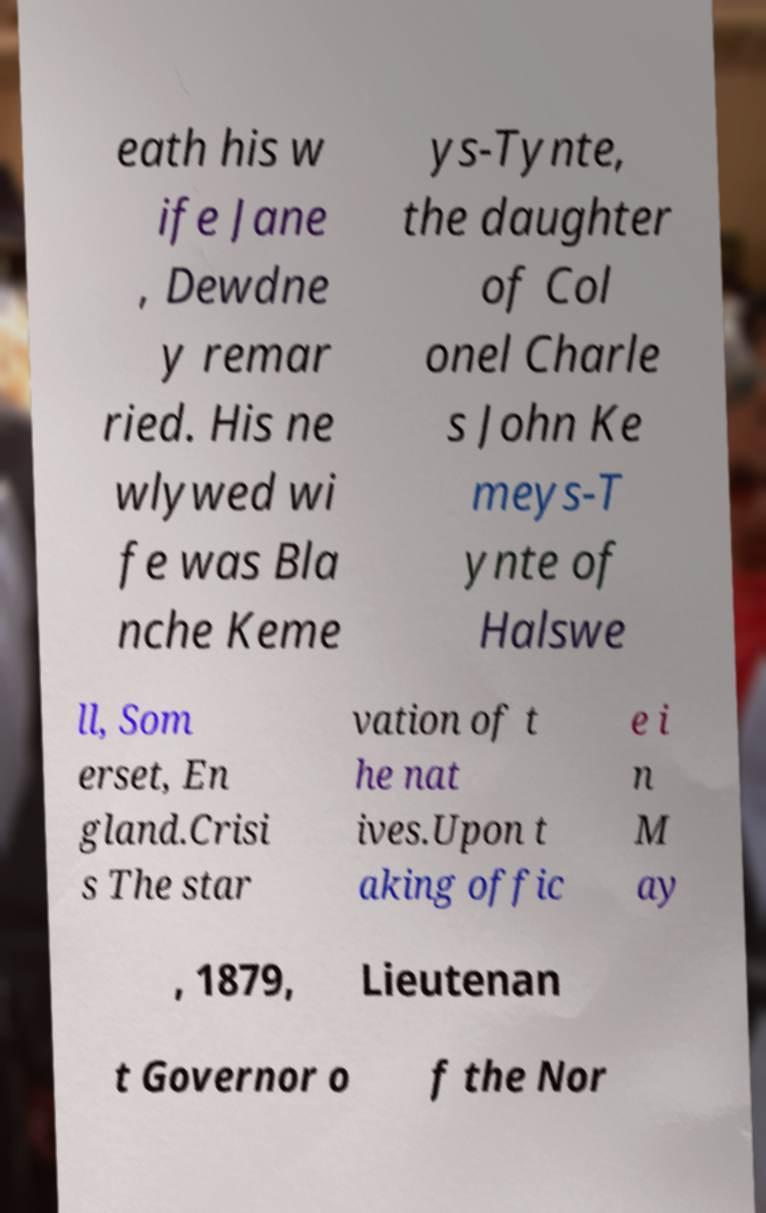Can you accurately transcribe the text from the provided image for me? eath his w ife Jane , Dewdne y remar ried. His ne wlywed wi fe was Bla nche Keme ys-Tynte, the daughter of Col onel Charle s John Ke meys-T ynte of Halswe ll, Som erset, En gland.Crisi s The star vation of t he nat ives.Upon t aking offic e i n M ay , 1879, Lieutenan t Governor o f the Nor 